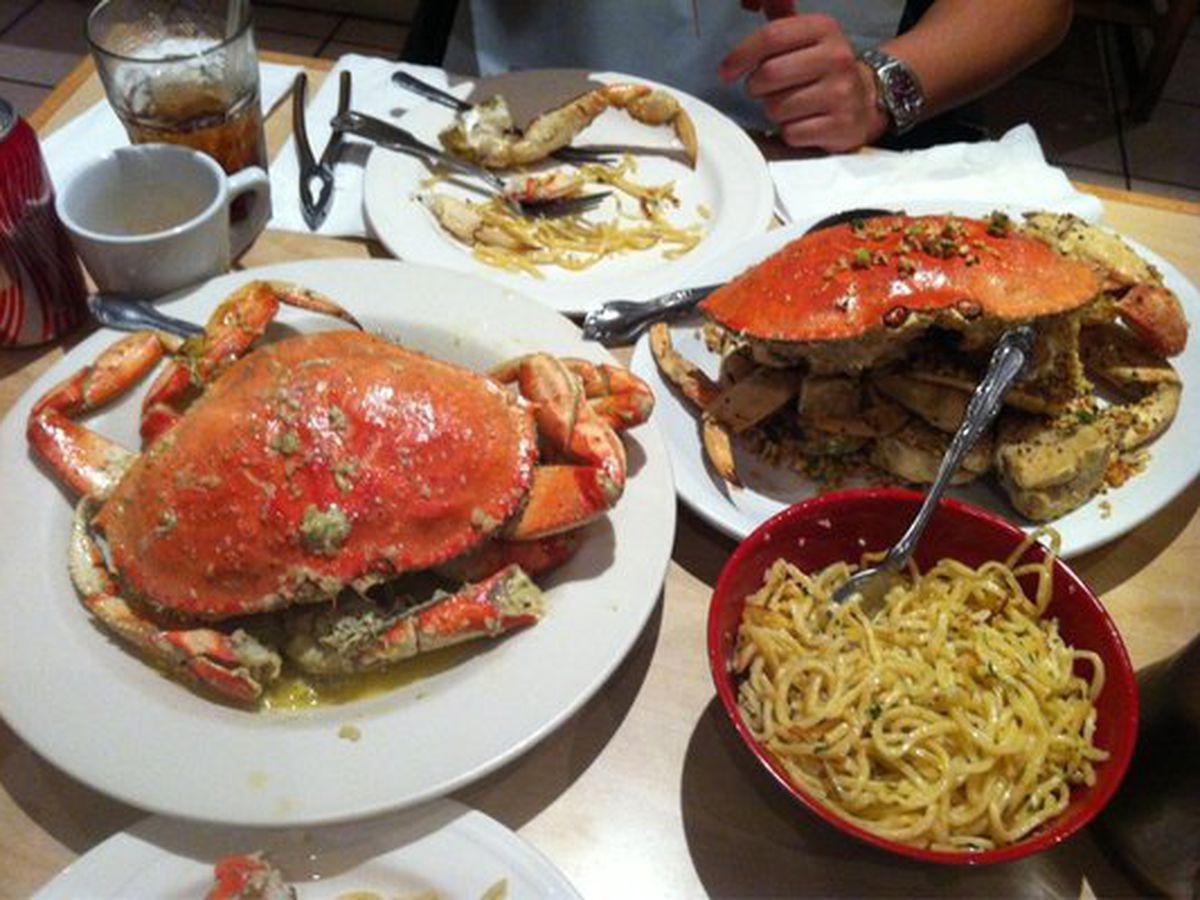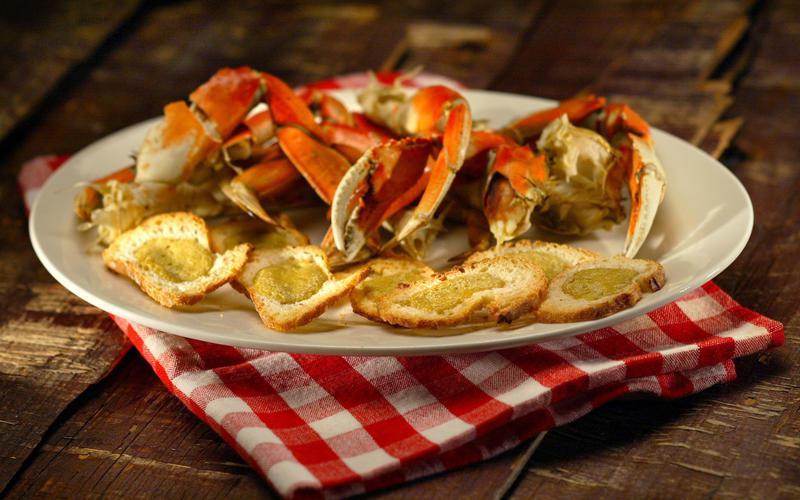The first image is the image on the left, the second image is the image on the right. For the images displayed, is the sentence "Each image contains exactly one round white plate that contains crab [and no other plates containing crab]." factually correct? Answer yes or no. No. The first image is the image on the left, the second image is the image on the right. Assess this claim about the two images: "There are two cooked crabs on a plate.". Correct or not? Answer yes or no. Yes. 